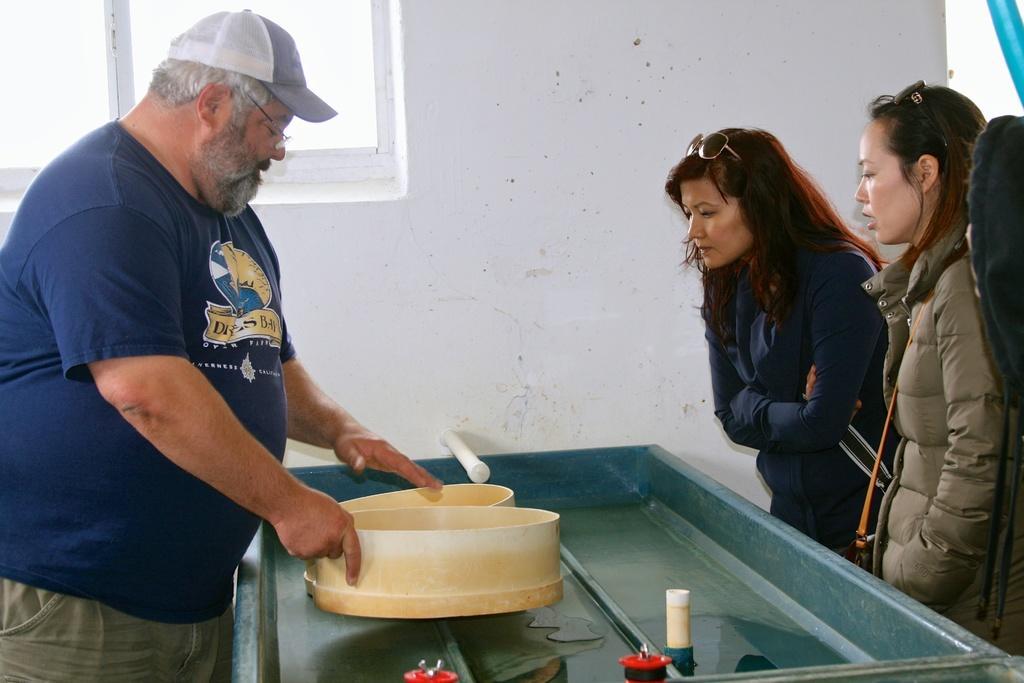Could you give a brief overview of what you see in this image? In this picture we can see a man and two women are standing, there is something present in the middle, in the background there is a wall and a window. 